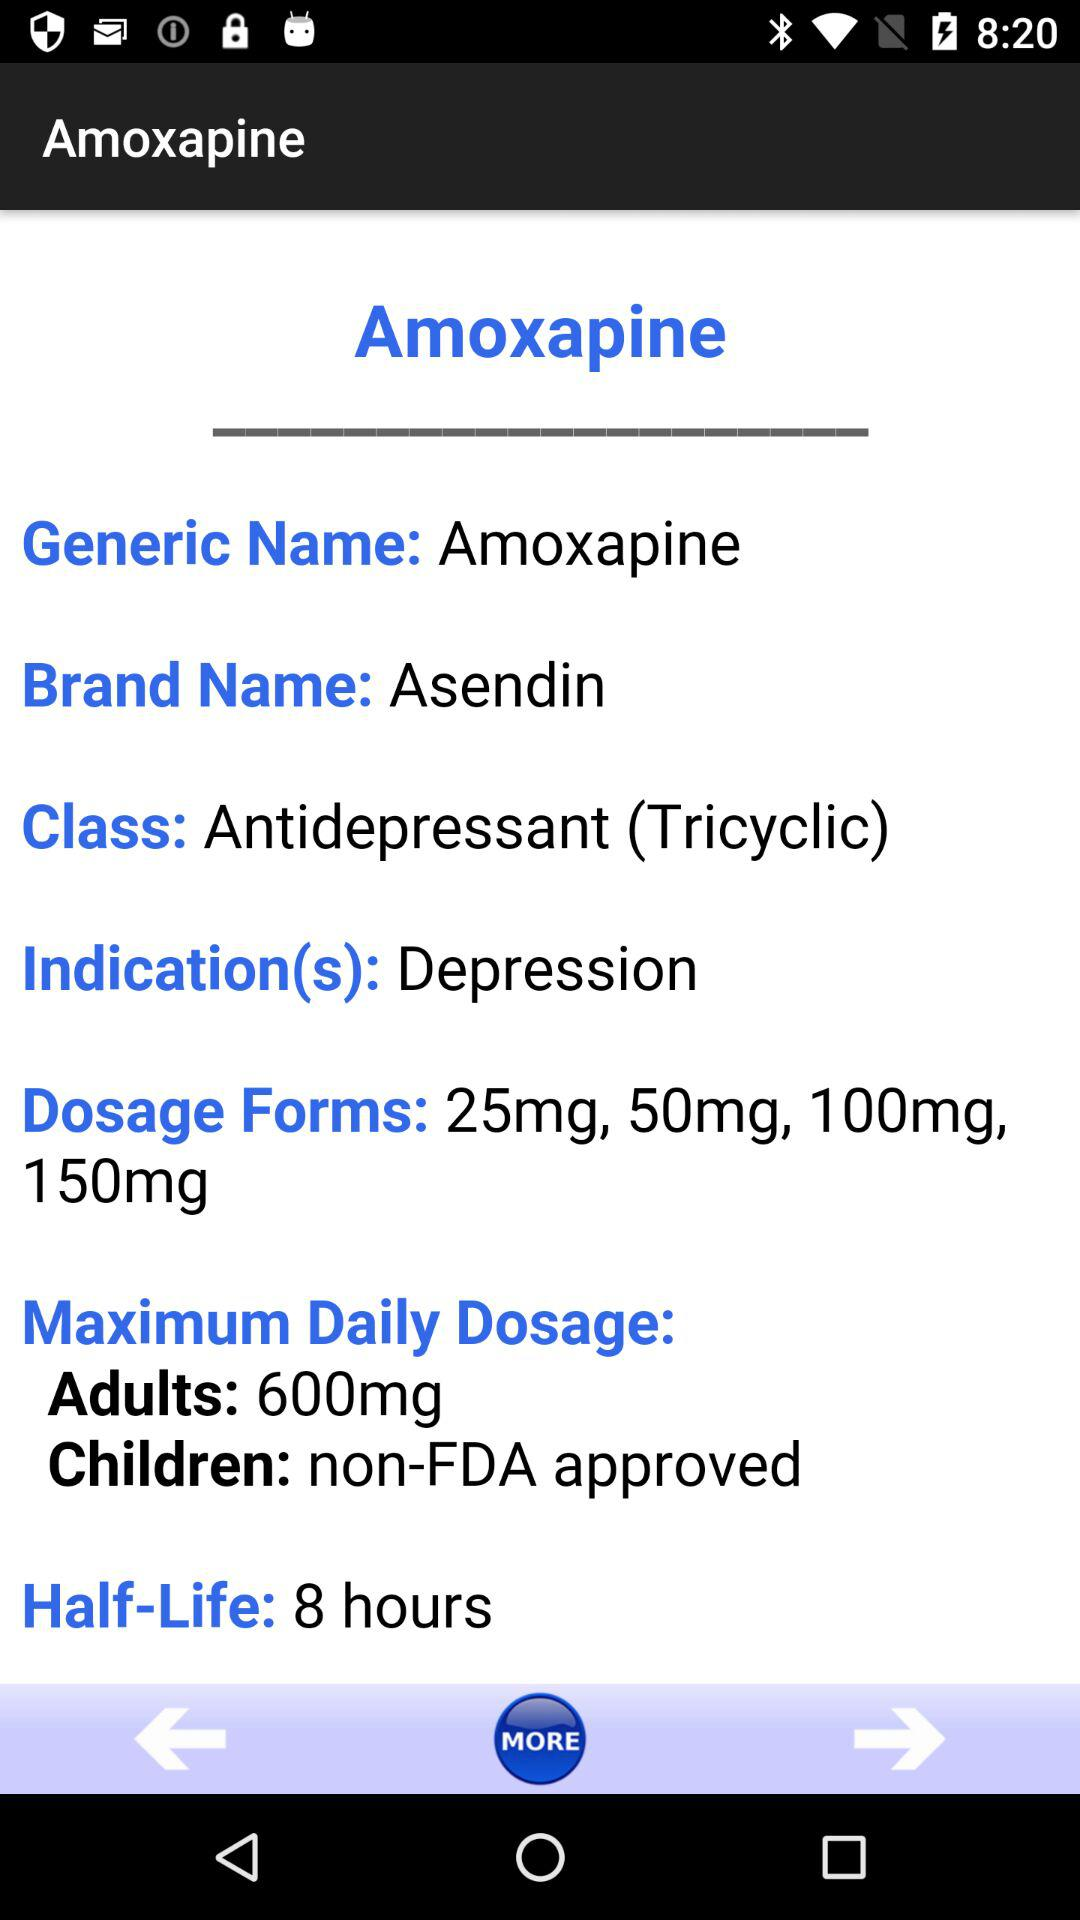What is the generic name? The generic name is amoxapine. 